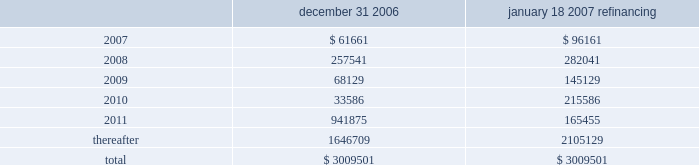Through the certegy merger , the company has an obligation to service $ 200 million ( aggregate principal amount ) of unsecured 4.75% ( 4.75 % ) fixed-rate notes due in 2008 .
The notes were recorded in purchase accounting at a discount of $ 5.7 million , which is being amortized over the term of the notes .
The notes accrue interest at a rate of 4.75% ( 4.75 % ) per year , payable semi-annually in arrears on each march 15 and september 15 .
On april 11 , 2005 , fis entered into interest rate swap agreements which have effectively fixed the interest rate at approximately 5.4% ( 5.4 % ) through april 2008 on $ 350 million of the term loan facilities ( or its replacement debt ) and at approximately 5.2% ( 5.2 % ) through april 2007 on an additional $ 350 million of the term loan .
The company has designated these interest rate swaps as cash flow hedges in accordance with sfas no .
133 .
The estimated fair value of the cash flow hedges results in an asset to the company of $ 4.9 million and $ 5.2 million , as of december 31 , 2006 and december 31 , 2005 , respectively , which is included in the accompanying consolidated balance sheets in other noncurrent assets and as a component of accumulated other comprehensive earnings , net of deferred taxes .
A portion of the amount included in accumulated other comprehensive earnings is reclassified into interest expense as a yield adjustment as interest payments are made on the term loan facilities .
The company 2019s existing cash flow hedges are highly effective and there is no current impact on earnings due to hedge ineffectiveness .
It is the policy of the company to execute such instruments with credit-worthy banks and not to enter into derivative financial instruments for speculative purposes .
Principal maturities at december 31 , 2006 ( and at december 31 , 2006 after giving effect to the debt refinancing completed on january 18 , 2007 ) for the next five years and thereafter are as follows ( in thousands ) : december 31 , january 18 , 2007 refinancing .
Fidelity national information services , inc .
And subsidiaries and affiliates consolidated and combined financial statements notes to consolidated and combined financial statements 2014 ( continued ) .
What is the percentage change in estimated fair value of the cash flow hedges from 2005 to 2006? 
Computations: ((4.9 - 5.2) / 5.2)
Answer: -0.05769. 